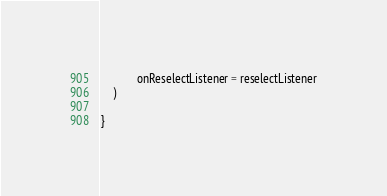Convert code to text. <code><loc_0><loc_0><loc_500><loc_500><_Kotlin_>            onReselectListener = reselectListener
    )

}

</code> 